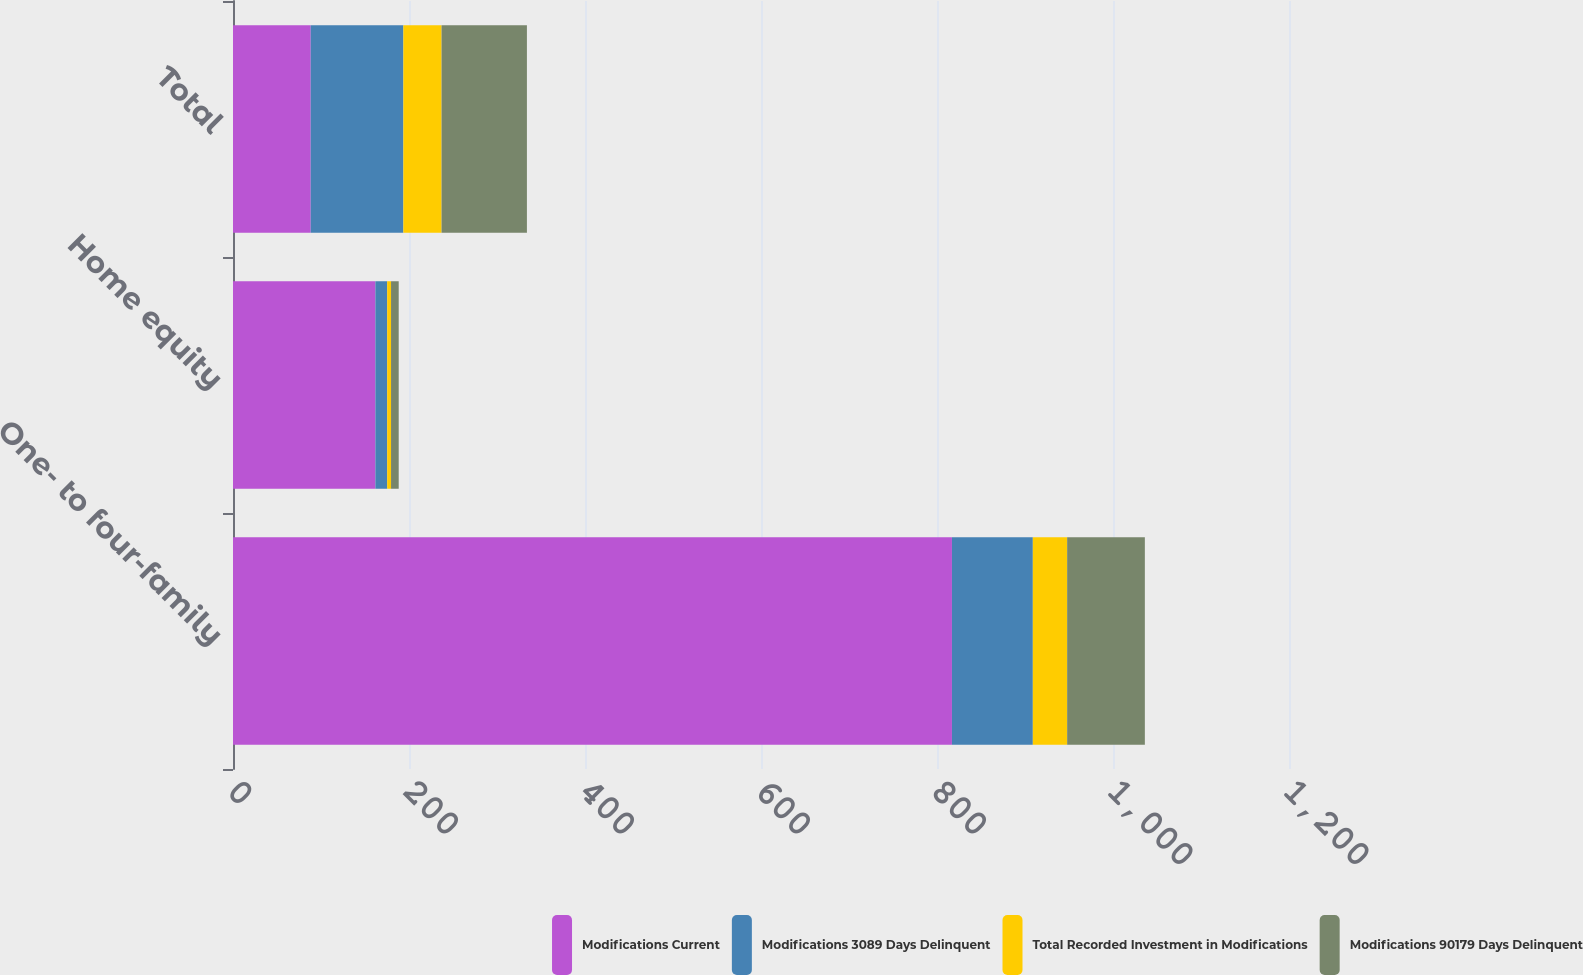<chart> <loc_0><loc_0><loc_500><loc_500><stacked_bar_chart><ecel><fcel>One- to four-family<fcel>Home equity<fcel>Total<nl><fcel>Modifications Current<fcel>817<fcel>161.8<fcel>88.3<nl><fcel>Modifications 3089 Days Delinquent<fcel>91.9<fcel>13.4<fcel>105.3<nl><fcel>Total Recorded Investment in Modifications<fcel>39<fcel>4.4<fcel>43.4<nl><fcel>Modifications 90179 Days Delinquent<fcel>88.3<fcel>8.7<fcel>97<nl></chart> 